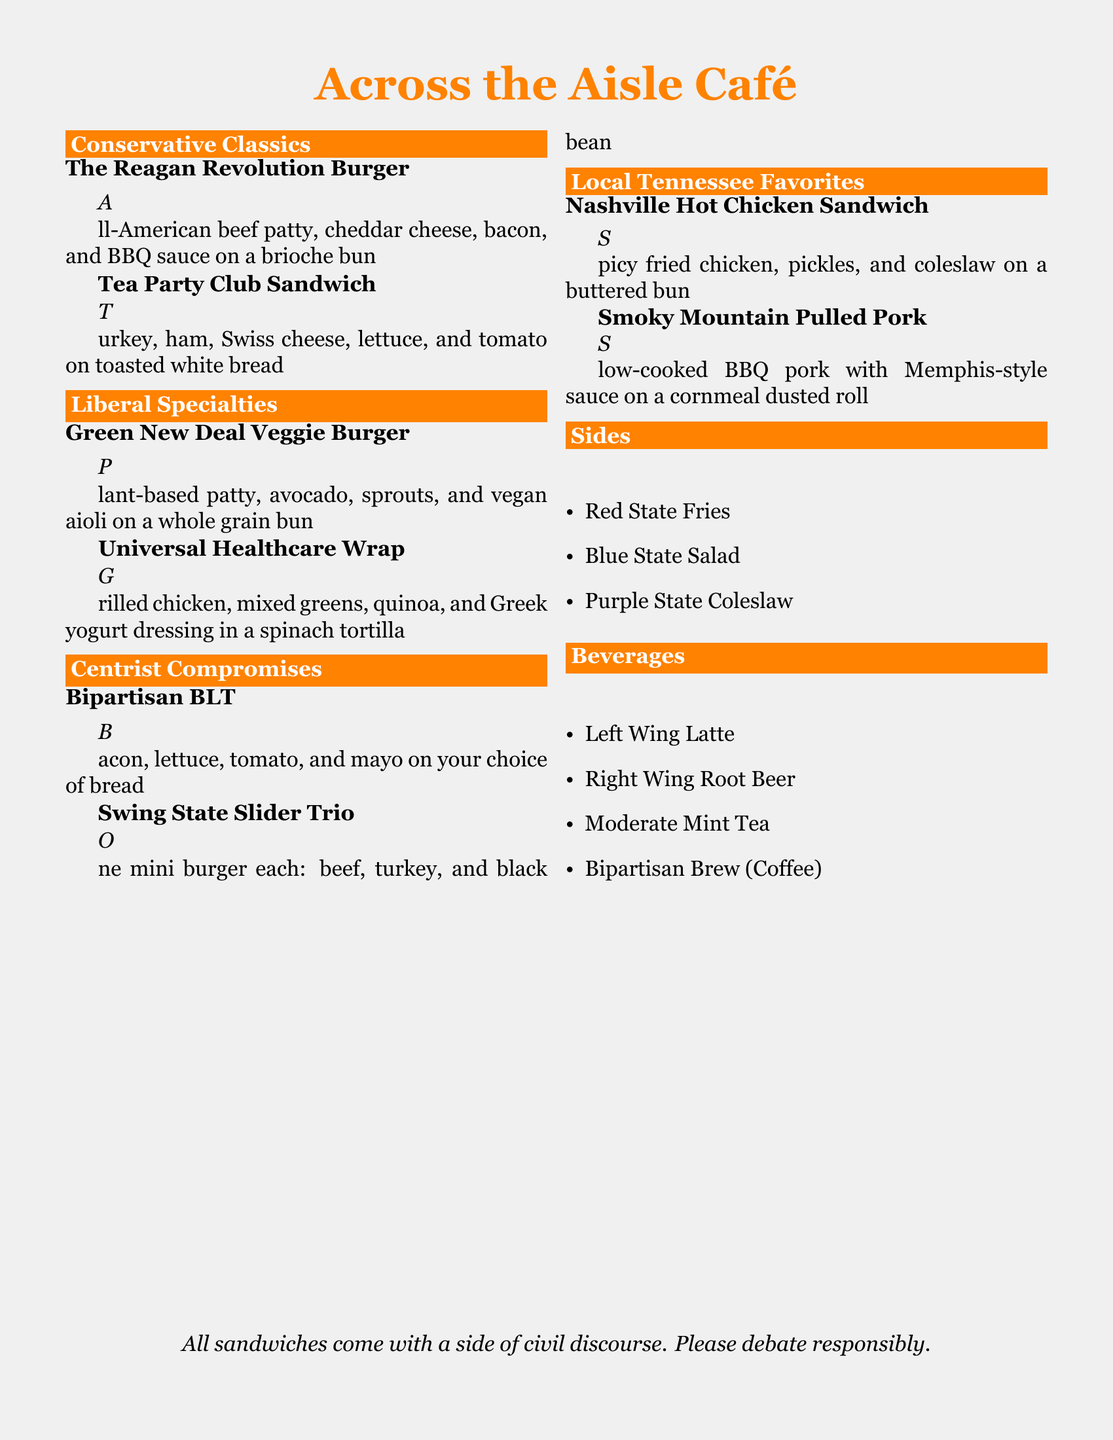What is the name of the burger in the Conservative Classics section? The name of the burger is listed under the Conservative Classics section, which includes "The Reagan Revolution Burger."
Answer: The Reagan Revolution Burger What type of sandwich is the Universal Healthcare Wrap? The Universal Healthcare Wrap is categorized under the Liberal Specialties, indicating its contents feature grilled chicken, mixed greens, quinoa, and Greek yogurt dressing.
Answer: Wrap How many sliders are in the Swing State Slider Trio? The Swing State Slider Trio features one mini burger of each type: beef, turkey, and black bean, indicating that there are three sliders total.
Answer: Three What is the beverage named that combines coffee from both political sides? The beverage is listed under the Beverages section, and it is named "Bipartisan Brew."
Answer: Bipartisan Brew What is included with every sandwich as stated in the menu? The menu humorously states that every sandwich comes with "a side of civil discourse."
Answer: A side of civil discourse 